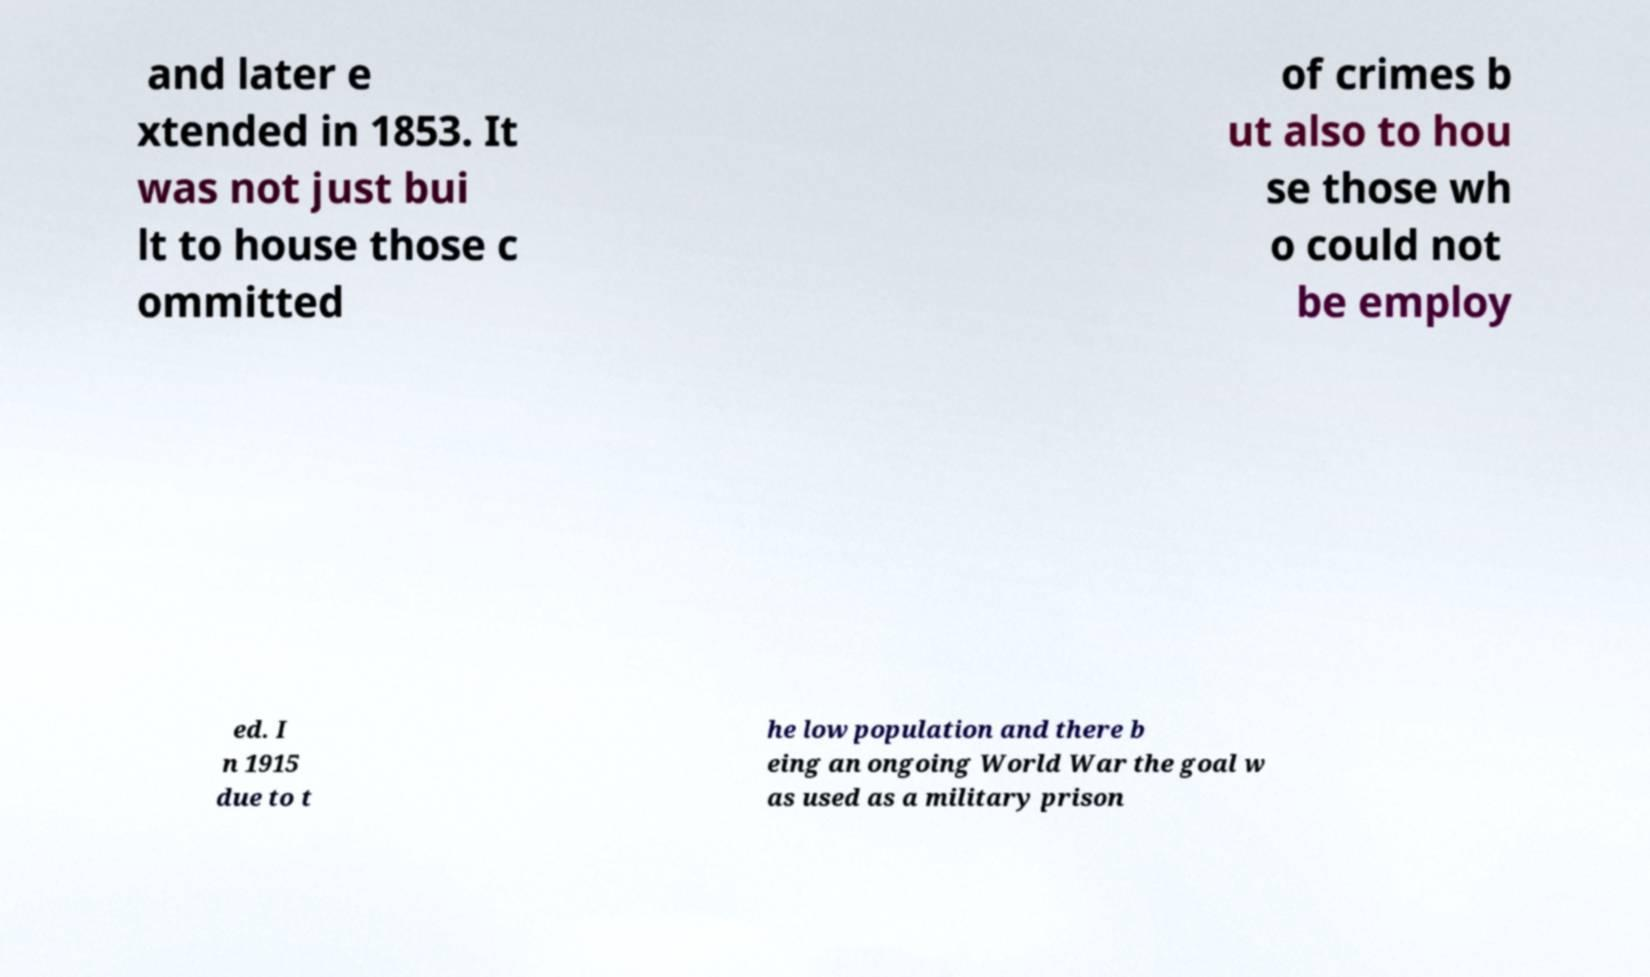Can you read and provide the text displayed in the image?This photo seems to have some interesting text. Can you extract and type it out for me? and later e xtended in 1853. It was not just bui lt to house those c ommitted of crimes b ut also to hou se those wh o could not be employ ed. I n 1915 due to t he low population and there b eing an ongoing World War the goal w as used as a military prison 